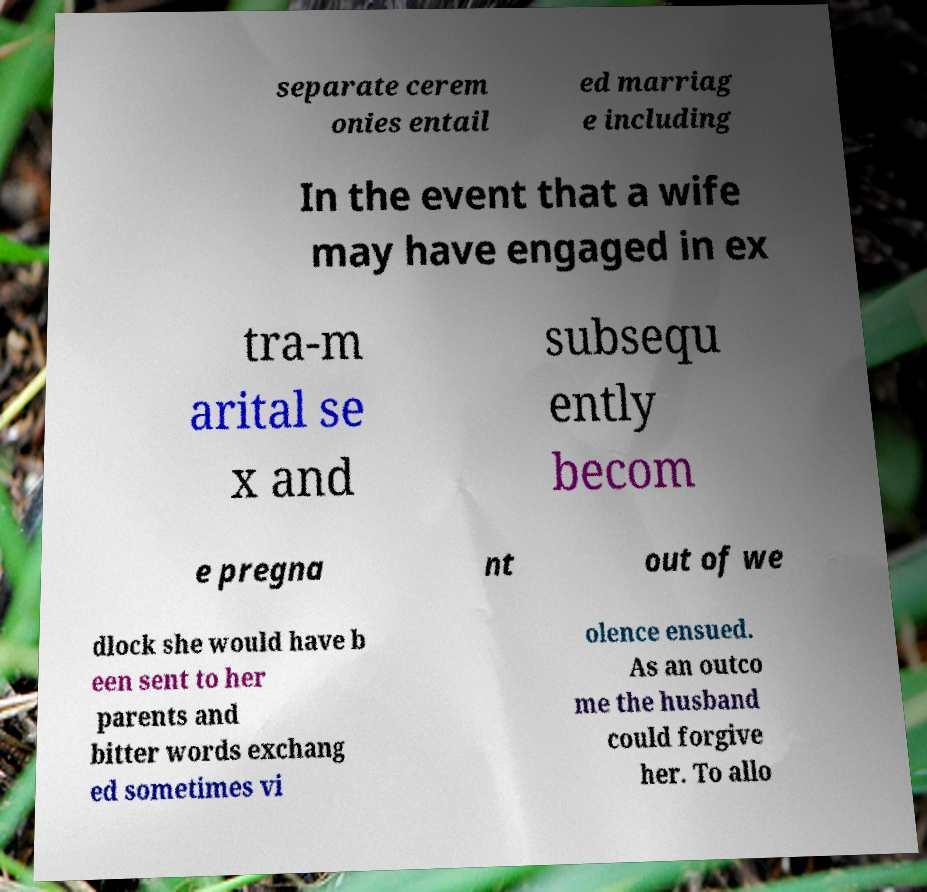What messages or text are displayed in this image? I need them in a readable, typed format. separate cerem onies entail ed marriag e including In the event that a wife may have engaged in ex tra-m arital se x and subsequ ently becom e pregna nt out of we dlock she would have b een sent to her parents and bitter words exchang ed sometimes vi olence ensued. As an outco me the husband could forgive her. To allo 